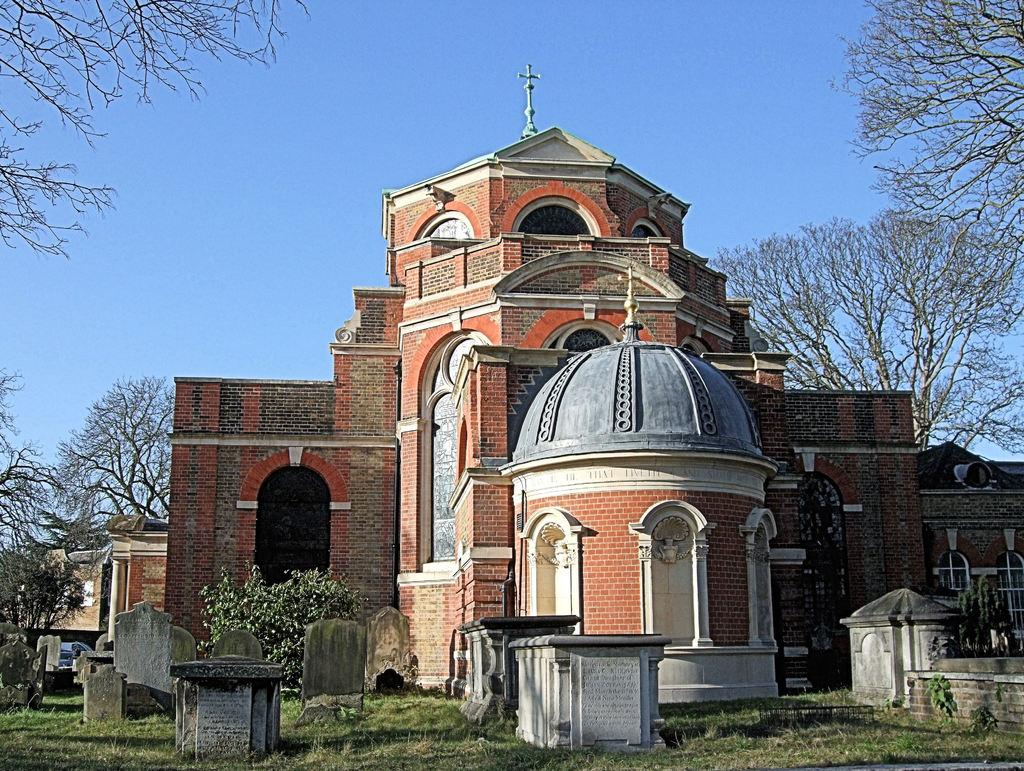What type of structures can be seen in the image? There are buildings in the image. What is located in front of the buildings? There are cemeteries in front of the buildings. What type of vegetation is present in the image? Grass is present in the image. What else can be seen in the image besides buildings and cemeteries? Trees are visible in the image. What type of cord is being used to hold up the trees in the image? There is no cord present in the image; the trees are standing on their own. 